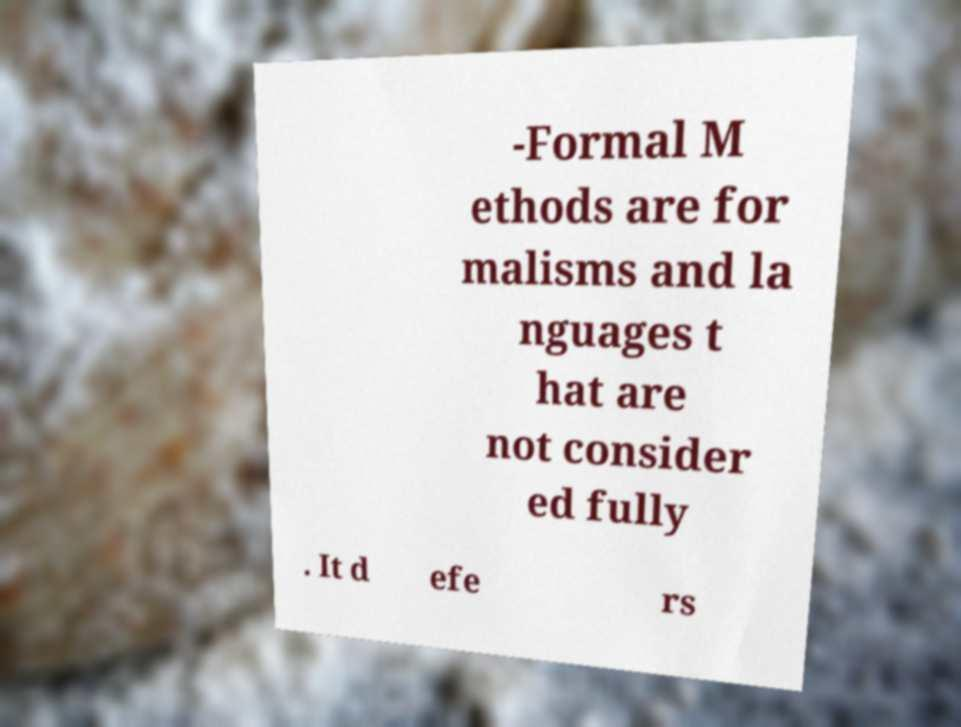Can you read and provide the text displayed in the image?This photo seems to have some interesting text. Can you extract and type it out for me? -Formal M ethods are for malisms and la nguages t hat are not consider ed fully . It d efe rs 